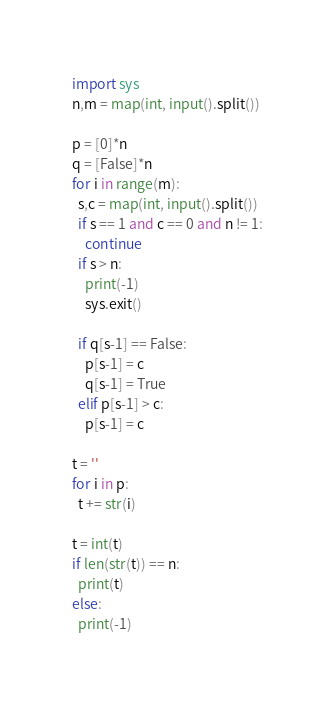<code> <loc_0><loc_0><loc_500><loc_500><_Python_>import sys
n,m = map(int, input().split())

p = [0]*n
q = [False]*n
for i in range(m):
  s,c = map(int, input().split())
  if s == 1 and c == 0 and n != 1:
    continue
  if s > n:
    print(-1)
    sys.exit()
    
  if q[s-1] == False:
    p[s-1] = c
    q[s-1] = True
  elif p[s-1] > c:
    p[s-1] = c

t = ''
for i in p:
  t += str(i)
  
t = int(t)
if len(str(t)) == n:
  print(t)
else:
  print(-1)</code> 